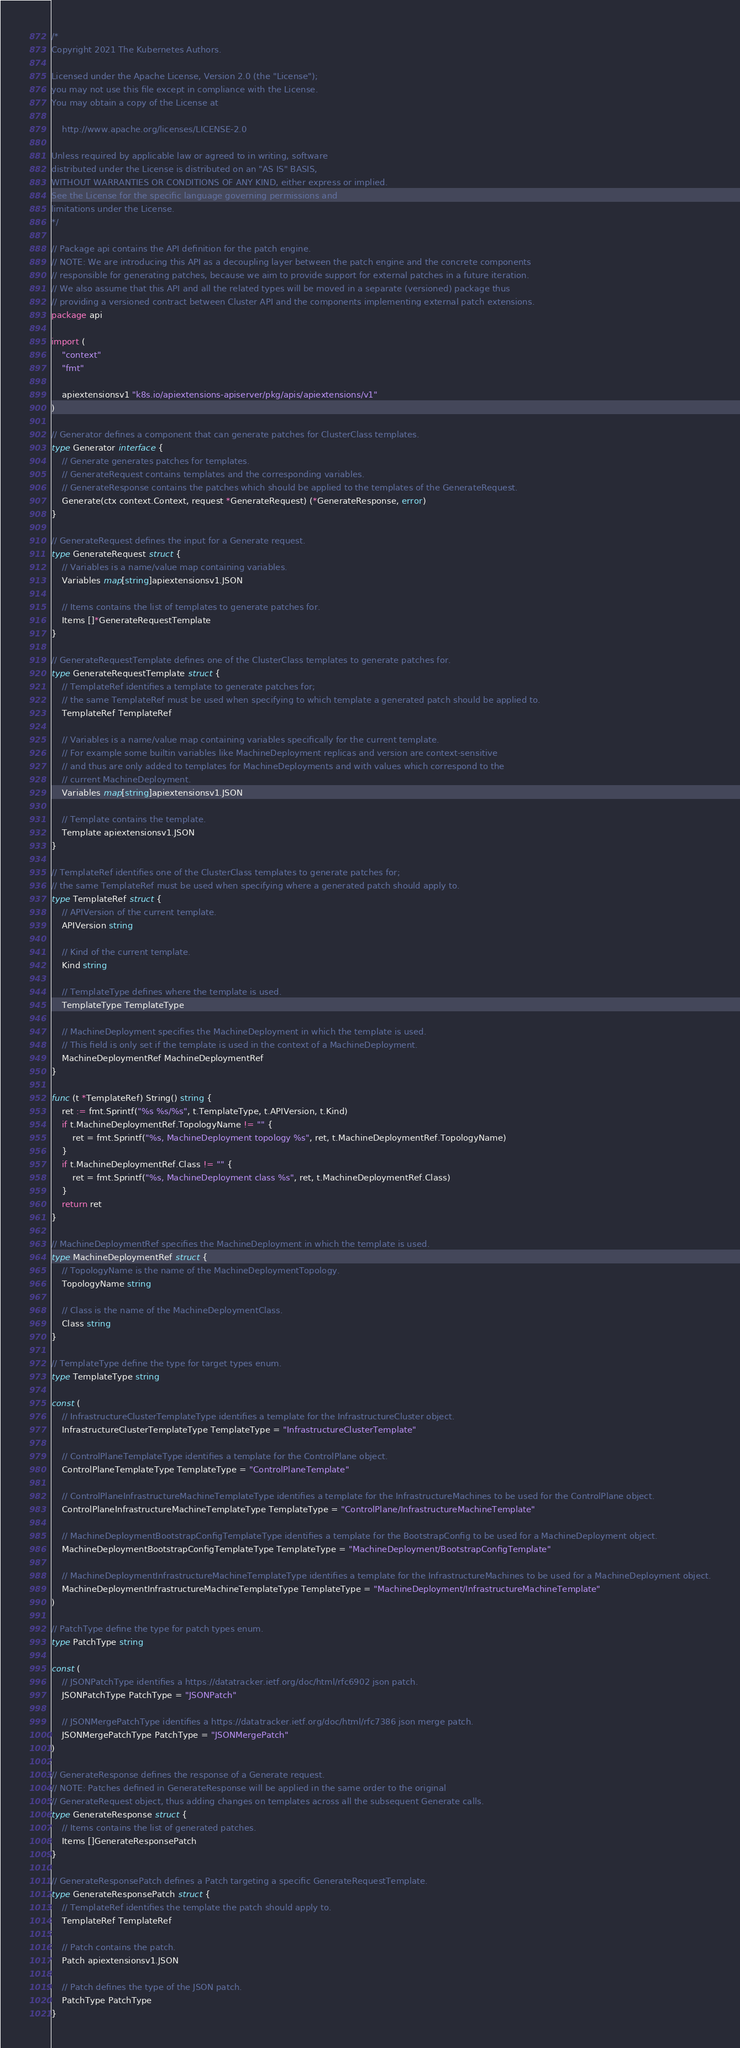Convert code to text. <code><loc_0><loc_0><loc_500><loc_500><_Go_>/*
Copyright 2021 The Kubernetes Authors.

Licensed under the Apache License, Version 2.0 (the "License");
you may not use this file except in compliance with the License.
You may obtain a copy of the License at

    http://www.apache.org/licenses/LICENSE-2.0

Unless required by applicable law or agreed to in writing, software
distributed under the License is distributed on an "AS IS" BASIS,
WITHOUT WARRANTIES OR CONDITIONS OF ANY KIND, either express or implied.
See the License for the specific language governing permissions and
limitations under the License.
*/

// Package api contains the API definition for the patch engine.
// NOTE: We are introducing this API as a decoupling layer between the patch engine and the concrete components
// responsible for generating patches, because we aim to provide support for external patches in a future iteration.
// We also assume that this API and all the related types will be moved in a separate (versioned) package thus
// providing a versioned contract between Cluster API and the components implementing external patch extensions.
package api

import (
	"context"
	"fmt"

	apiextensionsv1 "k8s.io/apiextensions-apiserver/pkg/apis/apiextensions/v1"
)

// Generator defines a component that can generate patches for ClusterClass templates.
type Generator interface {
	// Generate generates patches for templates.
	// GenerateRequest contains templates and the corresponding variables.
	// GenerateResponse contains the patches which should be applied to the templates of the GenerateRequest.
	Generate(ctx context.Context, request *GenerateRequest) (*GenerateResponse, error)
}

// GenerateRequest defines the input for a Generate request.
type GenerateRequest struct {
	// Variables is a name/value map containing variables.
	Variables map[string]apiextensionsv1.JSON

	// Items contains the list of templates to generate patches for.
	Items []*GenerateRequestTemplate
}

// GenerateRequestTemplate defines one of the ClusterClass templates to generate patches for.
type GenerateRequestTemplate struct {
	// TemplateRef identifies a template to generate patches for;
	// the same TemplateRef must be used when specifying to which template a generated patch should be applied to.
	TemplateRef TemplateRef

	// Variables is a name/value map containing variables specifically for the current template.
	// For example some builtin variables like MachineDeployment replicas and version are context-sensitive
	// and thus are only added to templates for MachineDeployments and with values which correspond to the
	// current MachineDeployment.
	Variables map[string]apiextensionsv1.JSON

	// Template contains the template.
	Template apiextensionsv1.JSON
}

// TemplateRef identifies one of the ClusterClass templates to generate patches for;
// the same TemplateRef must be used when specifying where a generated patch should apply to.
type TemplateRef struct {
	// APIVersion of the current template.
	APIVersion string

	// Kind of the current template.
	Kind string

	// TemplateType defines where the template is used.
	TemplateType TemplateType

	// MachineDeployment specifies the MachineDeployment in which the template is used.
	// This field is only set if the template is used in the context of a MachineDeployment.
	MachineDeploymentRef MachineDeploymentRef
}

func (t *TemplateRef) String() string {
	ret := fmt.Sprintf("%s %s/%s", t.TemplateType, t.APIVersion, t.Kind)
	if t.MachineDeploymentRef.TopologyName != "" {
		ret = fmt.Sprintf("%s, MachineDeployment topology %s", ret, t.MachineDeploymentRef.TopologyName)
	}
	if t.MachineDeploymentRef.Class != "" {
		ret = fmt.Sprintf("%s, MachineDeployment class %s", ret, t.MachineDeploymentRef.Class)
	}
	return ret
}

// MachineDeploymentRef specifies the MachineDeployment in which the template is used.
type MachineDeploymentRef struct {
	// TopologyName is the name of the MachineDeploymentTopology.
	TopologyName string

	// Class is the name of the MachineDeploymentClass.
	Class string
}

// TemplateType define the type for target types enum.
type TemplateType string

const (
	// InfrastructureClusterTemplateType identifies a template for the InfrastructureCluster object.
	InfrastructureClusterTemplateType TemplateType = "InfrastructureClusterTemplate"

	// ControlPlaneTemplateType identifies a template for the ControlPlane object.
	ControlPlaneTemplateType TemplateType = "ControlPlaneTemplate"

	// ControlPlaneInfrastructureMachineTemplateType identifies a template for the InfrastructureMachines to be used for the ControlPlane object.
	ControlPlaneInfrastructureMachineTemplateType TemplateType = "ControlPlane/InfrastructureMachineTemplate"

	// MachineDeploymentBootstrapConfigTemplateType identifies a template for the BootstrapConfig to be used for a MachineDeployment object.
	MachineDeploymentBootstrapConfigTemplateType TemplateType = "MachineDeployment/BootstrapConfigTemplate"

	// MachineDeploymentInfrastructureMachineTemplateType identifies a template for the InfrastructureMachines to be used for a MachineDeployment object.
	MachineDeploymentInfrastructureMachineTemplateType TemplateType = "MachineDeployment/InfrastructureMachineTemplate"
)

// PatchType define the type for patch types enum.
type PatchType string

const (
	// JSONPatchType identifies a https://datatracker.ietf.org/doc/html/rfc6902 json patch.
	JSONPatchType PatchType = "JSONPatch"

	// JSONMergePatchType identifies a https://datatracker.ietf.org/doc/html/rfc7386 json merge patch.
	JSONMergePatchType PatchType = "JSONMergePatch"
)

// GenerateResponse defines the response of a Generate request.
// NOTE: Patches defined in GenerateResponse will be applied in the same order to the original
// GenerateRequest object, thus adding changes on templates across all the subsequent Generate calls.
type GenerateResponse struct {
	// Items contains the list of generated patches.
	Items []GenerateResponsePatch
}

// GenerateResponsePatch defines a Patch targeting a specific GenerateRequestTemplate.
type GenerateResponsePatch struct {
	// TemplateRef identifies the template the patch should apply to.
	TemplateRef TemplateRef

	// Patch contains the patch.
	Patch apiextensionsv1.JSON

	// Patch defines the type of the JSON patch.
	PatchType PatchType
}
</code> 